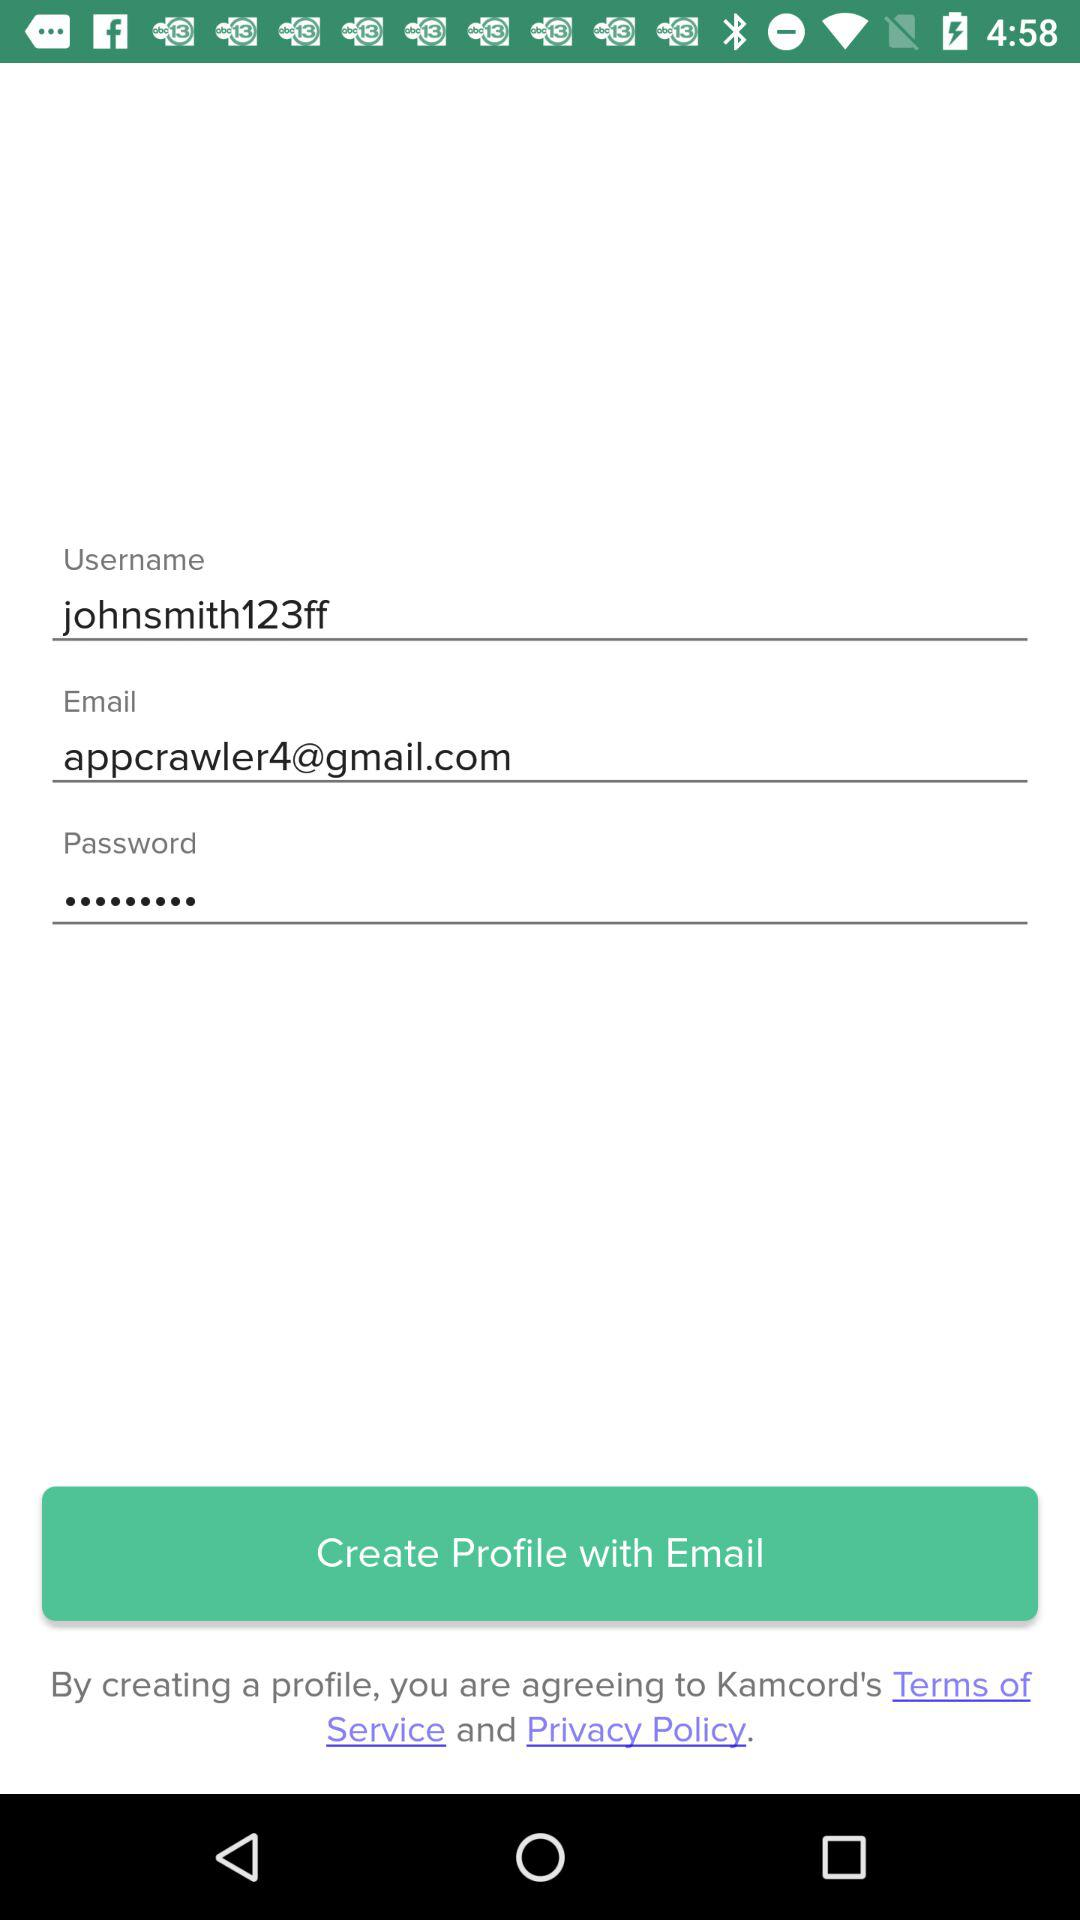What is the email address? The email address is appcrawler4@gmail.com. 